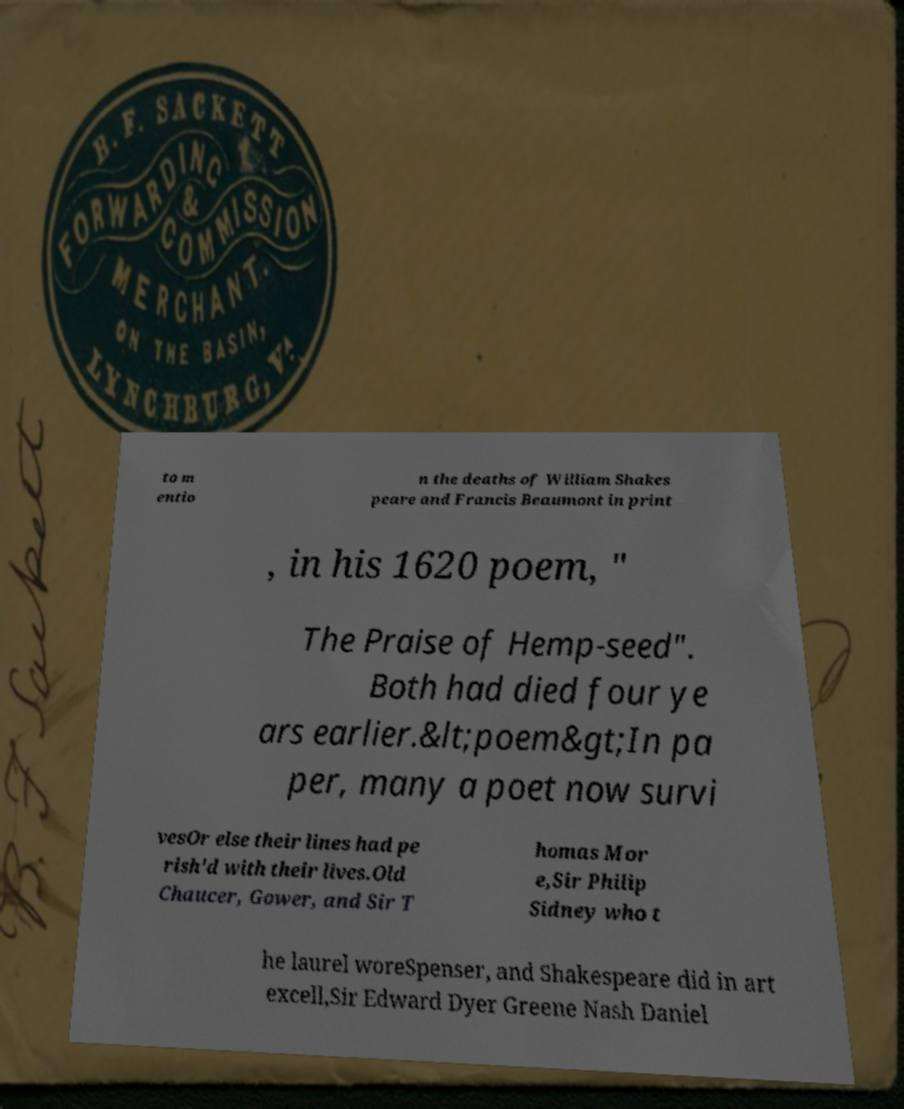For documentation purposes, I need the text within this image transcribed. Could you provide that? to m entio n the deaths of William Shakes peare and Francis Beaumont in print , in his 1620 poem, " The Praise of Hemp-seed". Both had died four ye ars earlier.&lt;poem&gt;In pa per, many a poet now survi vesOr else their lines had pe rish'd with their lives.Old Chaucer, Gower, and Sir T homas Mor e,Sir Philip Sidney who t he laurel woreSpenser, and Shakespeare did in art excell,Sir Edward Dyer Greene Nash Daniel 